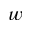Convert formula to latex. <formula><loc_0><loc_0><loc_500><loc_500>w</formula> 